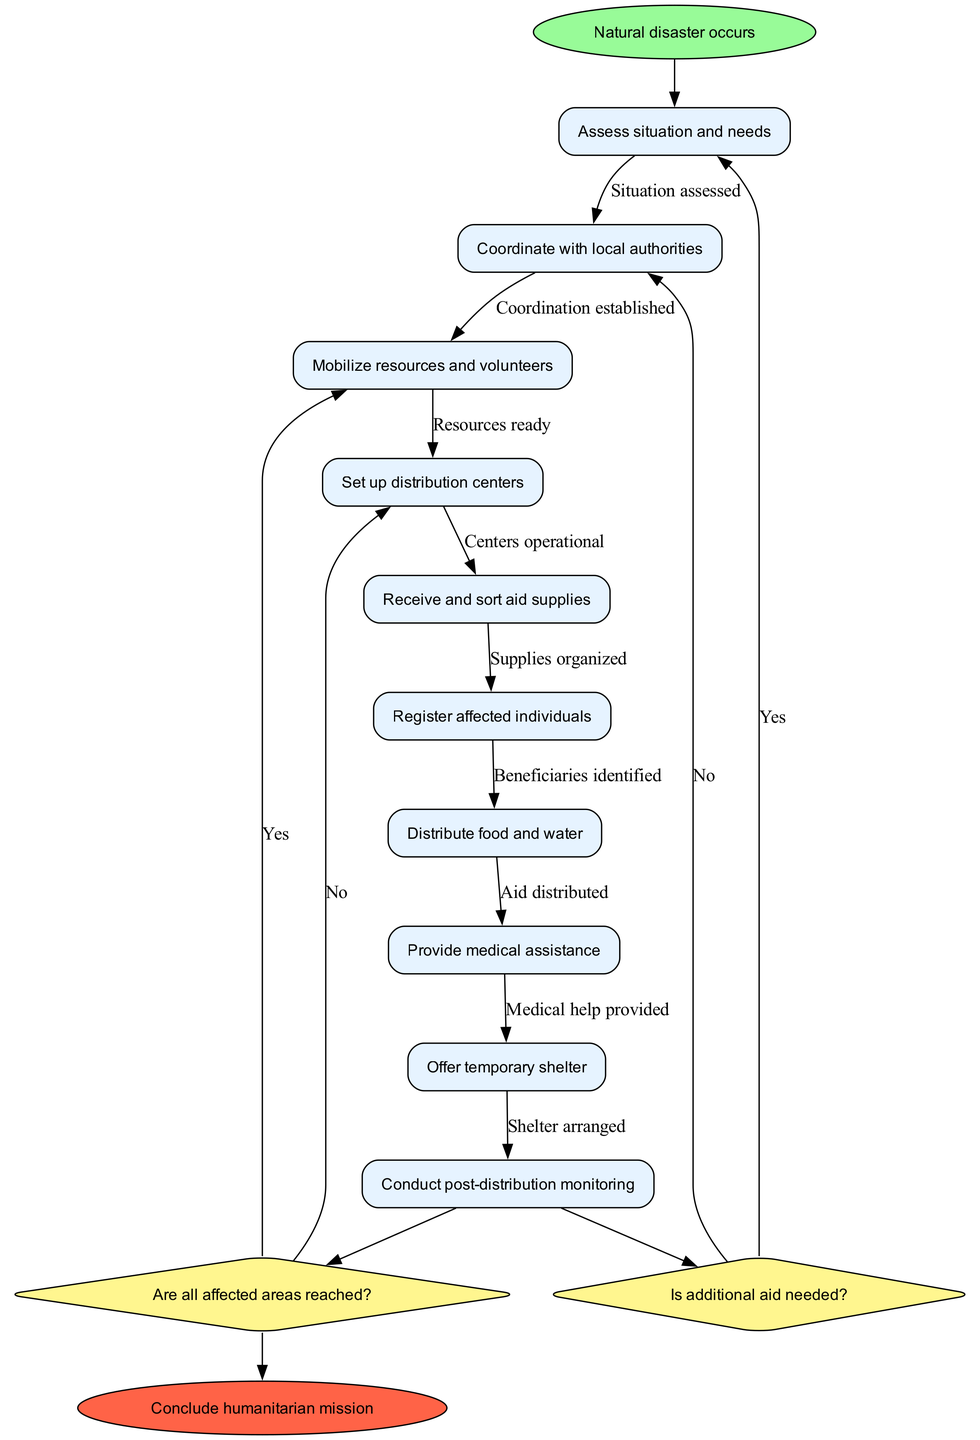What is the starting point of the workflow? The diagram indicates that the starting point is "Natural disaster occurs." This is the first node from which all activities initiate.
Answer: Natural disaster occurs What is the last activity before any decision is made? The last activity before the first decision node is "Distribute food and water." This is the final step in the sequence of activities conducted before branching out to decision-making.
Answer: Distribute food and water How many activities are depicted in the diagram? The diagram lists a total of ten activities involved in the humanitarian aid workflow, which include assessing the situation and providing medical assistance.
Answer: 10 What question is posed at the first decision node? The first decision node poses the question "Is additional aid needed?" This question determines if the operation requires further resources.
Answer: Is additional aid needed? After the final decision, what is the concluding action in the workflow? The concluding action in the workflow, after all decisions and activities, is to "Conclude humanitarian mission," which signifies the end of the operations.
Answer: Conclude humanitarian mission Which activity follows "Register affected individuals"? The activity that follows "Register affected individuals" is "Distribute food and water." This continues the flow from identifying beneficiaries to providing them with essential supplies.
Answer: Distribute food and water If the answer to the first decision node is "No," what is the next step? If the answer to the first decision node "Is additional aid needed?" is "No," the next step is to "Continue current operations," which implies maintaining the current level of aid activities.
Answer: Continue current operations What happens if all affected areas are reached? If all affected areas are reached following the second decision node, the workflow indicates that the next step is to "Prepare exit strategy," which involves planning the conclusion of the mission.
Answer: Prepare exit strategy 